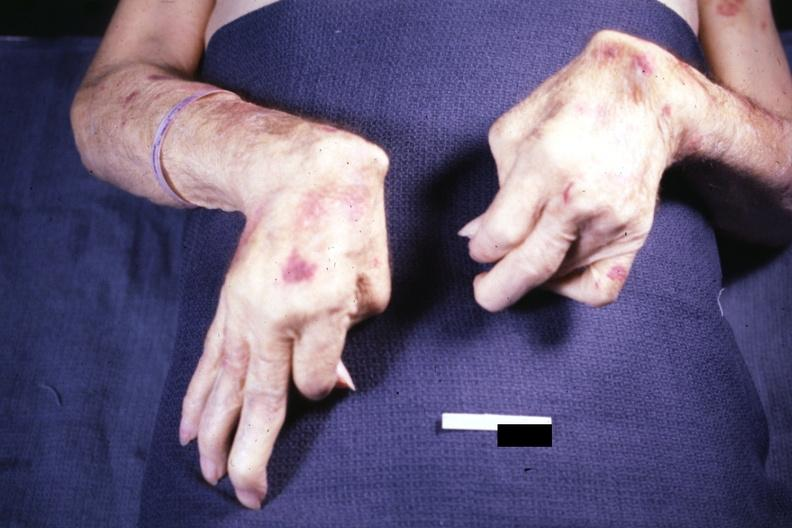re pagets disease present?
Answer the question using a single word or phrase. No 